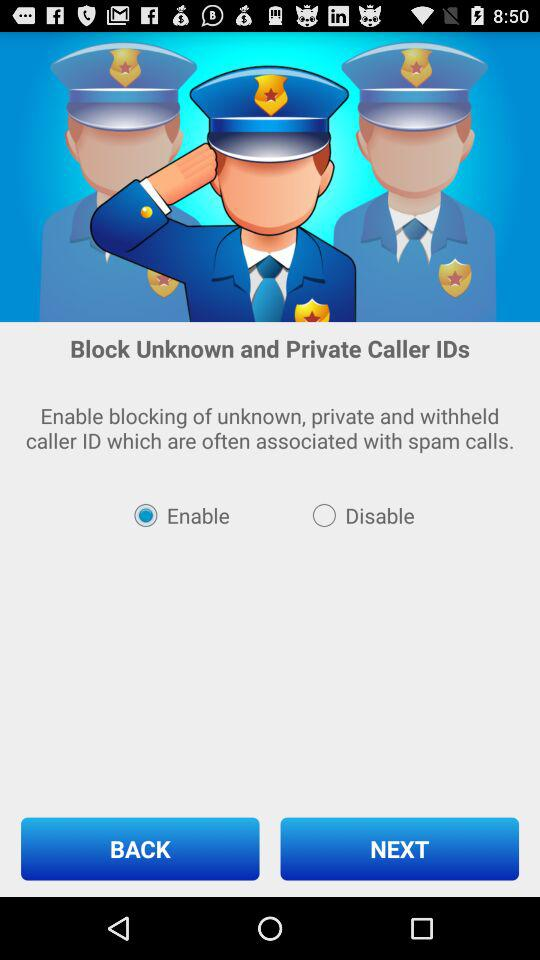Which option has been selected? The selected option is Enable. 